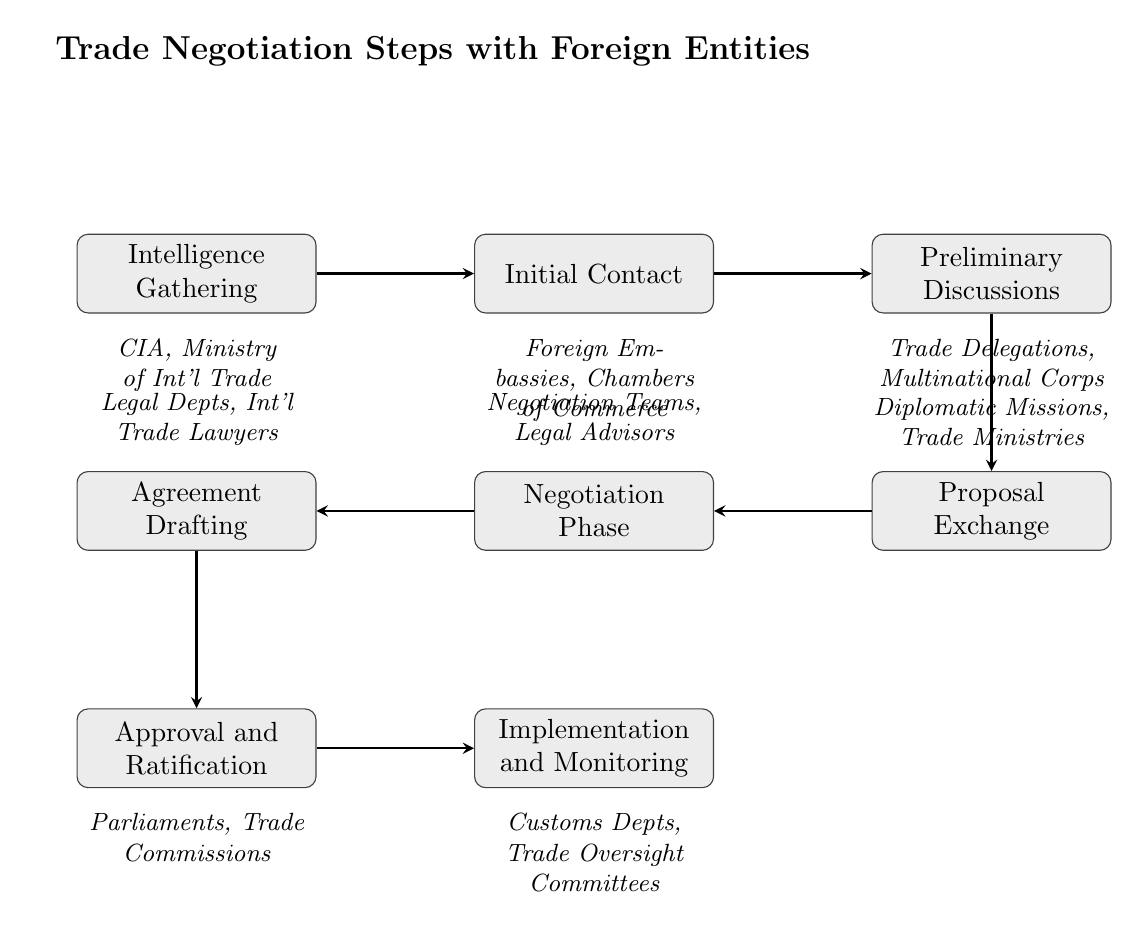What is the first step in the trade negotiation process? The diagram lists "Intelligence Gathering" as the first step, which is the starting point of the flow.
Answer: Intelligence Gathering How many steps are there in total in the diagram? By counting each step from "Intelligence Gathering" to "Implementation and Monitoring," I find there are eight distinct steps shown in the flow chart.
Answer: 8 Which entities are associated with the "Initial Contact" step? The diagram shows "Foreign Embassies" and "Chambers of Commerce" below the "Initial Contact" node, indicating these entities play a role at this stage.
Answer: Foreign Embassies, Chambers of Commerce What follows "Proposal Exchange" in the trade negotiation flow? The arrow leading from "Proposal Exchange" connects to the next step called "Negotiation Phase," indicating that it follows sequentially.
Answer: Negotiation Phase Which step involves "Legal Advisors"? The diagram identifies "Negotiation Phase" as involving "Legal Advisors," clearly indicated above that node, thus showing their participation in that step.
Answer: Negotiation Phase What is the final step in the trade negotiation process? The last step indicated in the flow is "Implementation and Monitoring," which marks the conclusion of the trade negotiation process according to the diagram.
Answer: Implementation and Monitoring How many entities are listed for the "Agreement Drafting" step? The diagram specifies "Legal Departments" and "International Trade Lawyers" as the two entities involved in the "Agreement Drafting" step, indicating a total of two.
Answer: 2 What step is directly above the "Approval and Ratification" step? The flow of the diagram shows that the step directly above "Approval and Ratification" is "Agreement Drafting," establishing a clear vertical relationship between them.
Answer: Agreement Drafting What is the main activity described in the "Negotiation Phase"? The description for "Negotiation Phase" highlights engaging in detailed talks to reconcile differences and agree on terms, focusing on the essence of negotiations.
Answer: Engage in detailed talks 